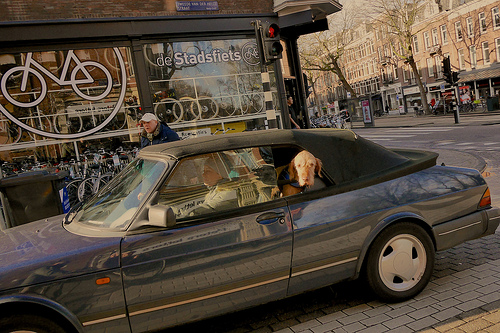<image>
Is the shop behind the car? Yes. From this viewpoint, the shop is positioned behind the car, with the car partially or fully occluding the shop. 